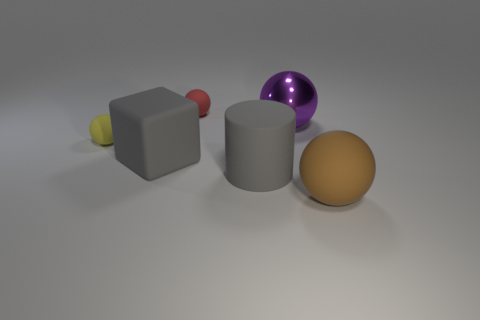Subtract all big purple metal balls. How many balls are left? 3 Add 3 purple shiny spheres. How many objects exist? 9 Subtract all red balls. How many balls are left? 3 Subtract all balls. How many objects are left? 2 Subtract all cyan cylinders. Subtract all yellow spheres. How many cylinders are left? 1 Subtract all blue matte spheres. Subtract all yellow spheres. How many objects are left? 5 Add 1 large brown rubber balls. How many large brown rubber balls are left? 2 Add 1 large yellow spheres. How many large yellow spheres exist? 1 Subtract 0 cyan blocks. How many objects are left? 6 